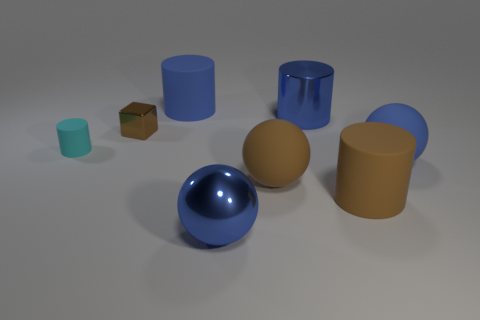Add 1 big blue matte balls. How many objects exist? 9 Subtract all large metal cylinders. How many cylinders are left? 3 Subtract all brown cubes. How many blue spheres are left? 2 Subtract all brown cylinders. How many cylinders are left? 3 Subtract 1 brown cubes. How many objects are left? 7 Subtract all blocks. How many objects are left? 7 Subtract all purple cylinders. Subtract all purple cubes. How many cylinders are left? 4 Subtract all yellow cylinders. Subtract all large things. How many objects are left? 2 Add 3 blue matte things. How many blue matte things are left? 5 Add 7 blue rubber blocks. How many blue rubber blocks exist? 7 